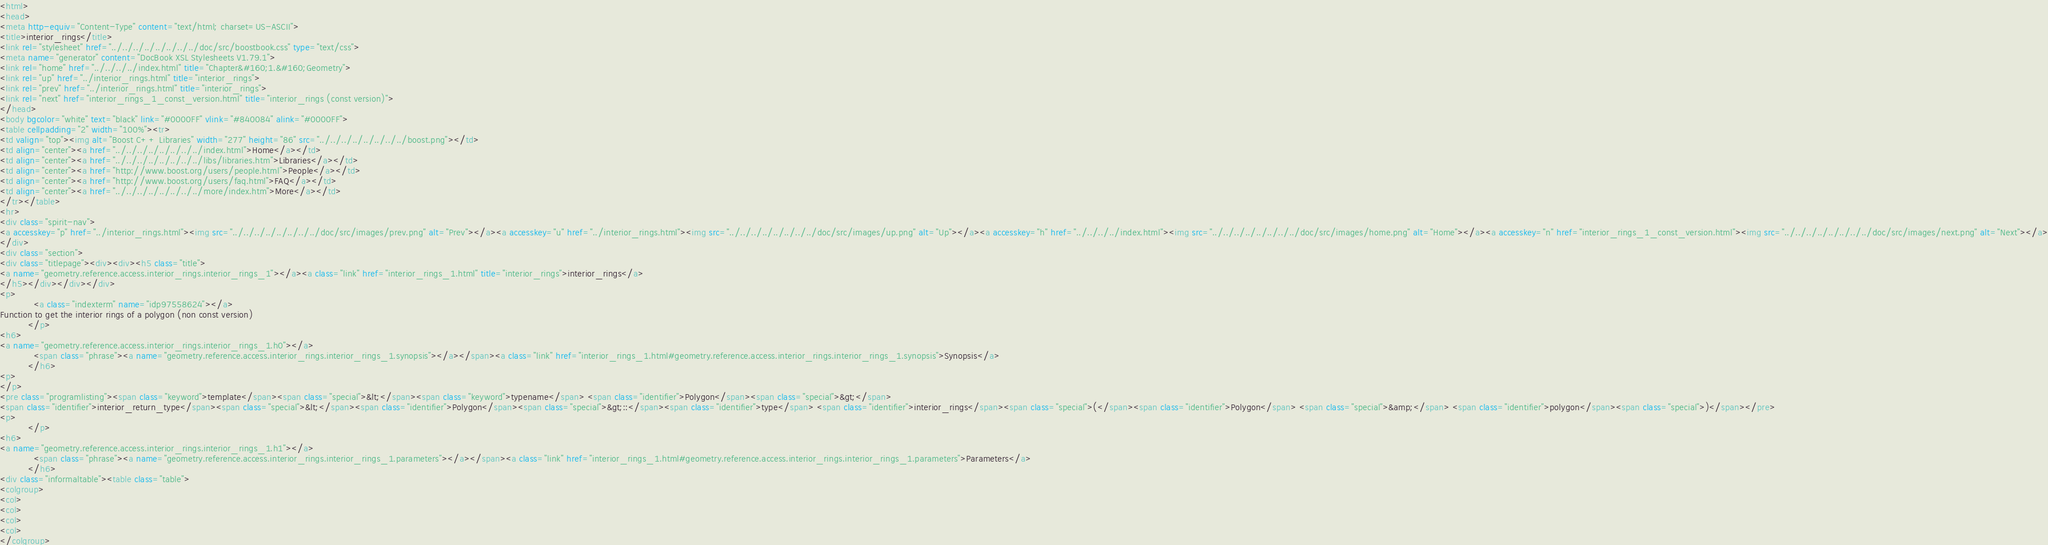Convert code to text. <code><loc_0><loc_0><loc_500><loc_500><_HTML_><html>
<head>
<meta http-equiv="Content-Type" content="text/html; charset=US-ASCII">
<title>interior_rings</title>
<link rel="stylesheet" href="../../../../../../../../doc/src/boostbook.css" type="text/css">
<meta name="generator" content="DocBook XSL Stylesheets V1.79.1">
<link rel="home" href="../../../../index.html" title="Chapter&#160;1.&#160;Geometry">
<link rel="up" href="../interior_rings.html" title="interior_rings">
<link rel="prev" href="../interior_rings.html" title="interior_rings">
<link rel="next" href="interior_rings_1_const_version.html" title="interior_rings (const version)">
</head>
<body bgcolor="white" text="black" link="#0000FF" vlink="#840084" alink="#0000FF">
<table cellpadding="2" width="100%"><tr>
<td valign="top"><img alt="Boost C++ Libraries" width="277" height="86" src="../../../../../../../../boost.png"></td>
<td align="center"><a href="../../../../../../../../index.html">Home</a></td>
<td align="center"><a href="../../../../../../../../libs/libraries.htm">Libraries</a></td>
<td align="center"><a href="http://www.boost.org/users/people.html">People</a></td>
<td align="center"><a href="http://www.boost.org/users/faq.html">FAQ</a></td>
<td align="center"><a href="../../../../../../../../more/index.htm">More</a></td>
</tr></table>
<hr>
<div class="spirit-nav">
<a accesskey="p" href="../interior_rings.html"><img src="../../../../../../../../doc/src/images/prev.png" alt="Prev"></a><a accesskey="u" href="../interior_rings.html"><img src="../../../../../../../../doc/src/images/up.png" alt="Up"></a><a accesskey="h" href="../../../../index.html"><img src="../../../../../../../../doc/src/images/home.png" alt="Home"></a><a accesskey="n" href="interior_rings_1_const_version.html"><img src="../../../../../../../../doc/src/images/next.png" alt="Next"></a>
</div>
<div class="section">
<div class="titlepage"><div><div><h5 class="title">
<a name="geometry.reference.access.interior_rings.interior_rings_1"></a><a class="link" href="interior_rings_1.html" title="interior_rings">interior_rings</a>
</h5></div></div></div>
<p>
            <a class="indexterm" name="idp97558624"></a>
Function to get the interior rings of a polygon (non const version)
          </p>
<h6>
<a name="geometry.reference.access.interior_rings.interior_rings_1.h0"></a>
            <span class="phrase"><a name="geometry.reference.access.interior_rings.interior_rings_1.synopsis"></a></span><a class="link" href="interior_rings_1.html#geometry.reference.access.interior_rings.interior_rings_1.synopsis">Synopsis</a>
          </h6>
<p>
</p>
<pre class="programlisting"><span class="keyword">template</span><span class="special">&lt;</span><span class="keyword">typename</span> <span class="identifier">Polygon</span><span class="special">&gt;</span>
<span class="identifier">interior_return_type</span><span class="special">&lt;</span><span class="identifier">Polygon</span><span class="special">&gt;::</span><span class="identifier">type</span> <span class="identifier">interior_rings</span><span class="special">(</span><span class="identifier">Polygon</span> <span class="special">&amp;</span> <span class="identifier">polygon</span><span class="special">)</span></pre>
<p>
          </p>
<h6>
<a name="geometry.reference.access.interior_rings.interior_rings_1.h1"></a>
            <span class="phrase"><a name="geometry.reference.access.interior_rings.interior_rings_1.parameters"></a></span><a class="link" href="interior_rings_1.html#geometry.reference.access.interior_rings.interior_rings_1.parameters">Parameters</a>
          </h6>
<div class="informaltable"><table class="table">
<colgroup>
<col>
<col>
<col>
<col>
</colgroup></code> 